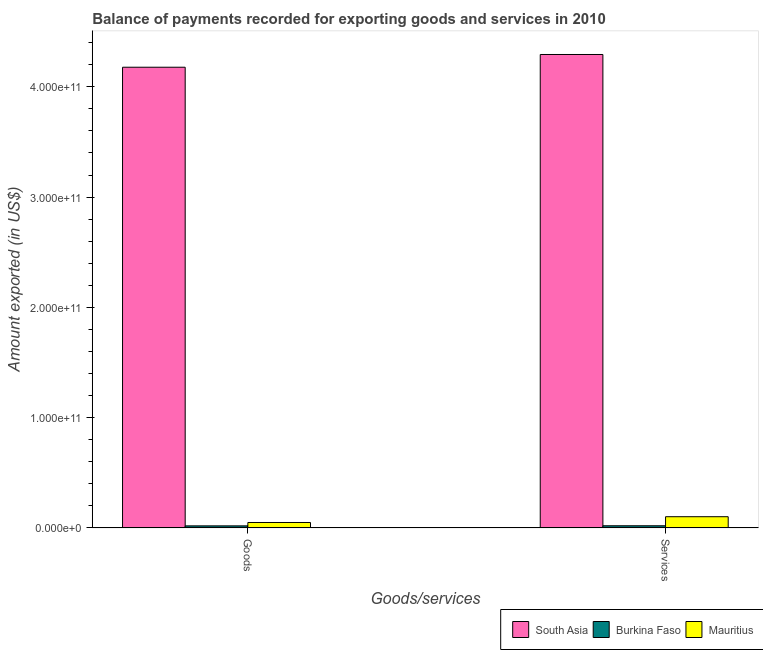Are the number of bars on each tick of the X-axis equal?
Your answer should be very brief. Yes. How many bars are there on the 1st tick from the left?
Give a very brief answer. 3. How many bars are there on the 1st tick from the right?
Provide a short and direct response. 3. What is the label of the 2nd group of bars from the left?
Make the answer very short. Services. What is the amount of services exported in Burkina Faso?
Offer a very short reply. 1.98e+09. Across all countries, what is the maximum amount of services exported?
Give a very brief answer. 4.29e+11. Across all countries, what is the minimum amount of goods exported?
Your answer should be very brief. 1.89e+09. In which country was the amount of services exported minimum?
Give a very brief answer. Burkina Faso. What is the total amount of services exported in the graph?
Offer a terse response. 4.41e+11. What is the difference between the amount of goods exported in South Asia and that in Burkina Faso?
Keep it short and to the point. 4.16e+11. What is the difference between the amount of services exported in Mauritius and the amount of goods exported in South Asia?
Your response must be concise. -4.08e+11. What is the average amount of services exported per country?
Provide a short and direct response. 1.47e+11. What is the difference between the amount of services exported and amount of goods exported in Burkina Faso?
Your answer should be very brief. 9.17e+07. What is the ratio of the amount of services exported in Mauritius to that in South Asia?
Your answer should be compact. 0.02. Is the amount of goods exported in Mauritius less than that in Burkina Faso?
Provide a short and direct response. No. In how many countries, is the amount of goods exported greater than the average amount of goods exported taken over all countries?
Provide a succinct answer. 1. What does the 3rd bar from the left in Goods represents?
Ensure brevity in your answer.  Mauritius. What does the 1st bar from the right in Services represents?
Ensure brevity in your answer.  Mauritius. How many bars are there?
Your response must be concise. 6. How many countries are there in the graph?
Offer a very short reply. 3. What is the difference between two consecutive major ticks on the Y-axis?
Provide a short and direct response. 1.00e+11. Are the values on the major ticks of Y-axis written in scientific E-notation?
Your answer should be compact. Yes. Does the graph contain any zero values?
Your response must be concise. No. How many legend labels are there?
Your answer should be very brief. 3. What is the title of the graph?
Offer a terse response. Balance of payments recorded for exporting goods and services in 2010. What is the label or title of the X-axis?
Ensure brevity in your answer.  Goods/services. What is the label or title of the Y-axis?
Ensure brevity in your answer.  Amount exported (in US$). What is the Amount exported (in US$) of South Asia in Goods?
Your response must be concise. 4.18e+11. What is the Amount exported (in US$) in Burkina Faso in Goods?
Your answer should be compact. 1.89e+09. What is the Amount exported (in US$) in Mauritius in Goods?
Keep it short and to the point. 4.96e+09. What is the Amount exported (in US$) of South Asia in Services?
Your answer should be compact. 4.29e+11. What is the Amount exported (in US$) of Burkina Faso in Services?
Your answer should be very brief. 1.98e+09. What is the Amount exported (in US$) in Mauritius in Services?
Keep it short and to the point. 1.02e+1. Across all Goods/services, what is the maximum Amount exported (in US$) in South Asia?
Provide a succinct answer. 4.29e+11. Across all Goods/services, what is the maximum Amount exported (in US$) of Burkina Faso?
Provide a short and direct response. 1.98e+09. Across all Goods/services, what is the maximum Amount exported (in US$) in Mauritius?
Make the answer very short. 1.02e+1. Across all Goods/services, what is the minimum Amount exported (in US$) of South Asia?
Make the answer very short. 4.18e+11. Across all Goods/services, what is the minimum Amount exported (in US$) of Burkina Faso?
Provide a short and direct response. 1.89e+09. Across all Goods/services, what is the minimum Amount exported (in US$) of Mauritius?
Provide a short and direct response. 4.96e+09. What is the total Amount exported (in US$) of South Asia in the graph?
Your answer should be very brief. 8.47e+11. What is the total Amount exported (in US$) of Burkina Faso in the graph?
Your answer should be very brief. 3.87e+09. What is the total Amount exported (in US$) of Mauritius in the graph?
Ensure brevity in your answer.  1.51e+1. What is the difference between the Amount exported (in US$) of South Asia in Goods and that in Services?
Provide a succinct answer. -1.15e+1. What is the difference between the Amount exported (in US$) in Burkina Faso in Goods and that in Services?
Offer a terse response. -9.17e+07. What is the difference between the Amount exported (in US$) of Mauritius in Goods and that in Services?
Ensure brevity in your answer.  -5.23e+09. What is the difference between the Amount exported (in US$) in South Asia in Goods and the Amount exported (in US$) in Burkina Faso in Services?
Offer a terse response. 4.16e+11. What is the difference between the Amount exported (in US$) in South Asia in Goods and the Amount exported (in US$) in Mauritius in Services?
Your answer should be compact. 4.08e+11. What is the difference between the Amount exported (in US$) of Burkina Faso in Goods and the Amount exported (in US$) of Mauritius in Services?
Provide a succinct answer. -8.30e+09. What is the average Amount exported (in US$) of South Asia per Goods/services?
Your answer should be very brief. 4.24e+11. What is the average Amount exported (in US$) of Burkina Faso per Goods/services?
Provide a succinct answer. 1.93e+09. What is the average Amount exported (in US$) in Mauritius per Goods/services?
Provide a short and direct response. 7.57e+09. What is the difference between the Amount exported (in US$) of South Asia and Amount exported (in US$) of Burkina Faso in Goods?
Offer a terse response. 4.16e+11. What is the difference between the Amount exported (in US$) in South Asia and Amount exported (in US$) in Mauritius in Goods?
Ensure brevity in your answer.  4.13e+11. What is the difference between the Amount exported (in US$) of Burkina Faso and Amount exported (in US$) of Mauritius in Goods?
Ensure brevity in your answer.  -3.07e+09. What is the difference between the Amount exported (in US$) in South Asia and Amount exported (in US$) in Burkina Faso in Services?
Ensure brevity in your answer.  4.27e+11. What is the difference between the Amount exported (in US$) of South Asia and Amount exported (in US$) of Mauritius in Services?
Give a very brief answer. 4.19e+11. What is the difference between the Amount exported (in US$) of Burkina Faso and Amount exported (in US$) of Mauritius in Services?
Your response must be concise. -8.21e+09. What is the ratio of the Amount exported (in US$) of South Asia in Goods to that in Services?
Offer a terse response. 0.97. What is the ratio of the Amount exported (in US$) of Burkina Faso in Goods to that in Services?
Give a very brief answer. 0.95. What is the ratio of the Amount exported (in US$) in Mauritius in Goods to that in Services?
Offer a very short reply. 0.49. What is the difference between the highest and the second highest Amount exported (in US$) in South Asia?
Your answer should be very brief. 1.15e+1. What is the difference between the highest and the second highest Amount exported (in US$) of Burkina Faso?
Provide a succinct answer. 9.17e+07. What is the difference between the highest and the second highest Amount exported (in US$) of Mauritius?
Your answer should be very brief. 5.23e+09. What is the difference between the highest and the lowest Amount exported (in US$) in South Asia?
Your response must be concise. 1.15e+1. What is the difference between the highest and the lowest Amount exported (in US$) of Burkina Faso?
Offer a very short reply. 9.17e+07. What is the difference between the highest and the lowest Amount exported (in US$) in Mauritius?
Keep it short and to the point. 5.23e+09. 